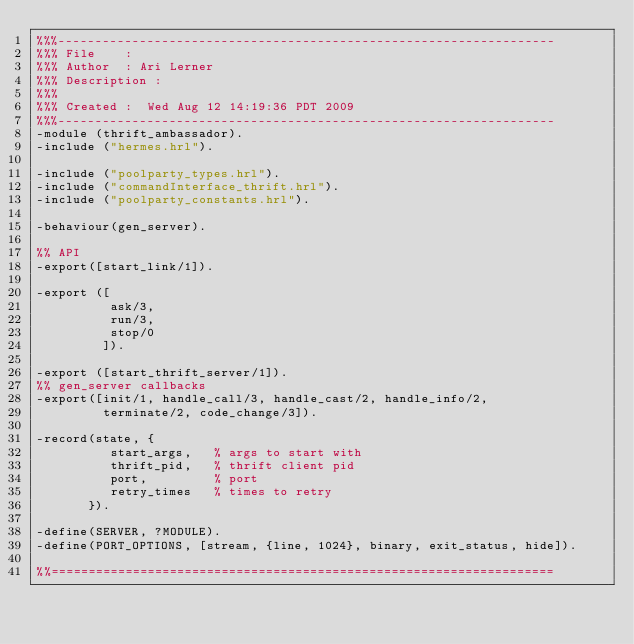Convert code to text. <code><loc_0><loc_0><loc_500><loc_500><_Erlang_>%%%-------------------------------------------------------------------
%%% File    : 
%%% Author  : Ari Lerner
%%% Description : 
%%%
%%% Created :  Wed Aug 12 14:19:36 PDT 2009
%%%-------------------------------------------------------------------
-module (thrift_ambassador).
-include ("hermes.hrl").

-include ("poolparty_types.hrl").
-include ("commandInterface_thrift.hrl").
-include ("poolparty_constants.hrl").

-behaviour(gen_server).

%% API
-export([start_link/1]).

-export ([
          ask/3,
          run/3,
          stop/0
         ]).

-export ([start_thrift_server/1]).
%% gen_server callbacks
-export([init/1, handle_call/3, handle_cast/2, handle_info/2,
         terminate/2, code_change/3]).

-record(state, {
          start_args,   % args to start with
          thrift_pid,   % thrift client pid
          port,         % port
          retry_times   % times to retry
       }).
                 
-define(SERVER, ?MODULE).
-define(PORT_OPTIONS, [stream, {line, 1024}, binary, exit_status, hide]).

%%====================================================================</code> 